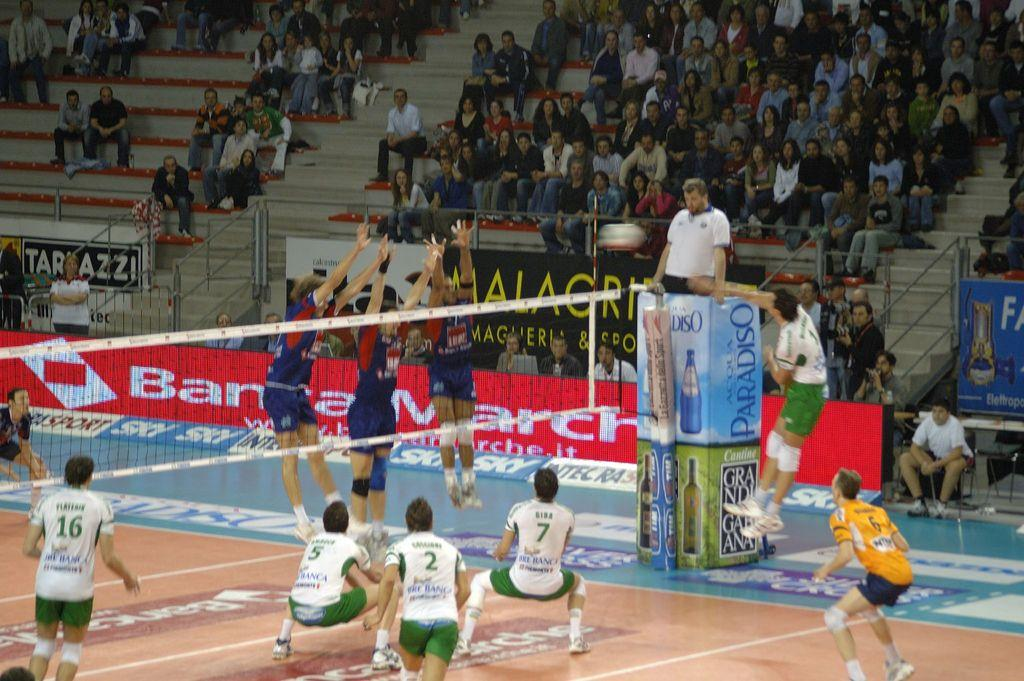<image>
Give a short and clear explanation of the subsequent image. A person with a 5 on their jersey squats down on a court with other players. 